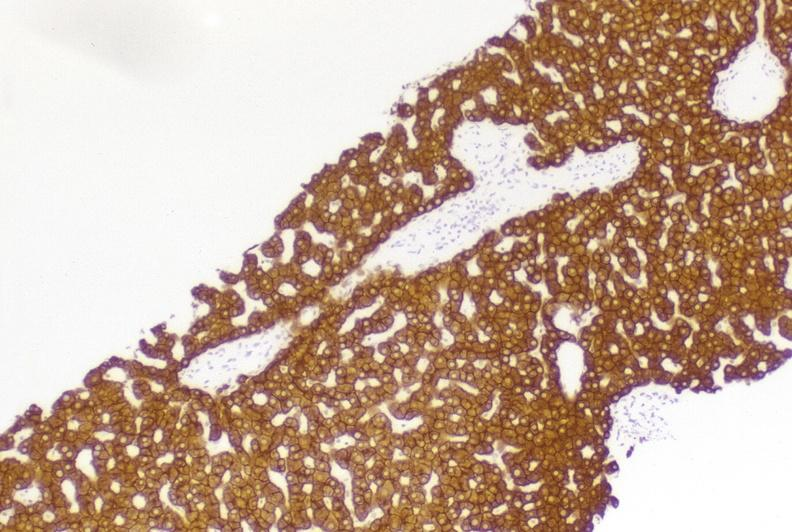s hepatobiliary present?
Answer the question using a single word or phrase. Yes 